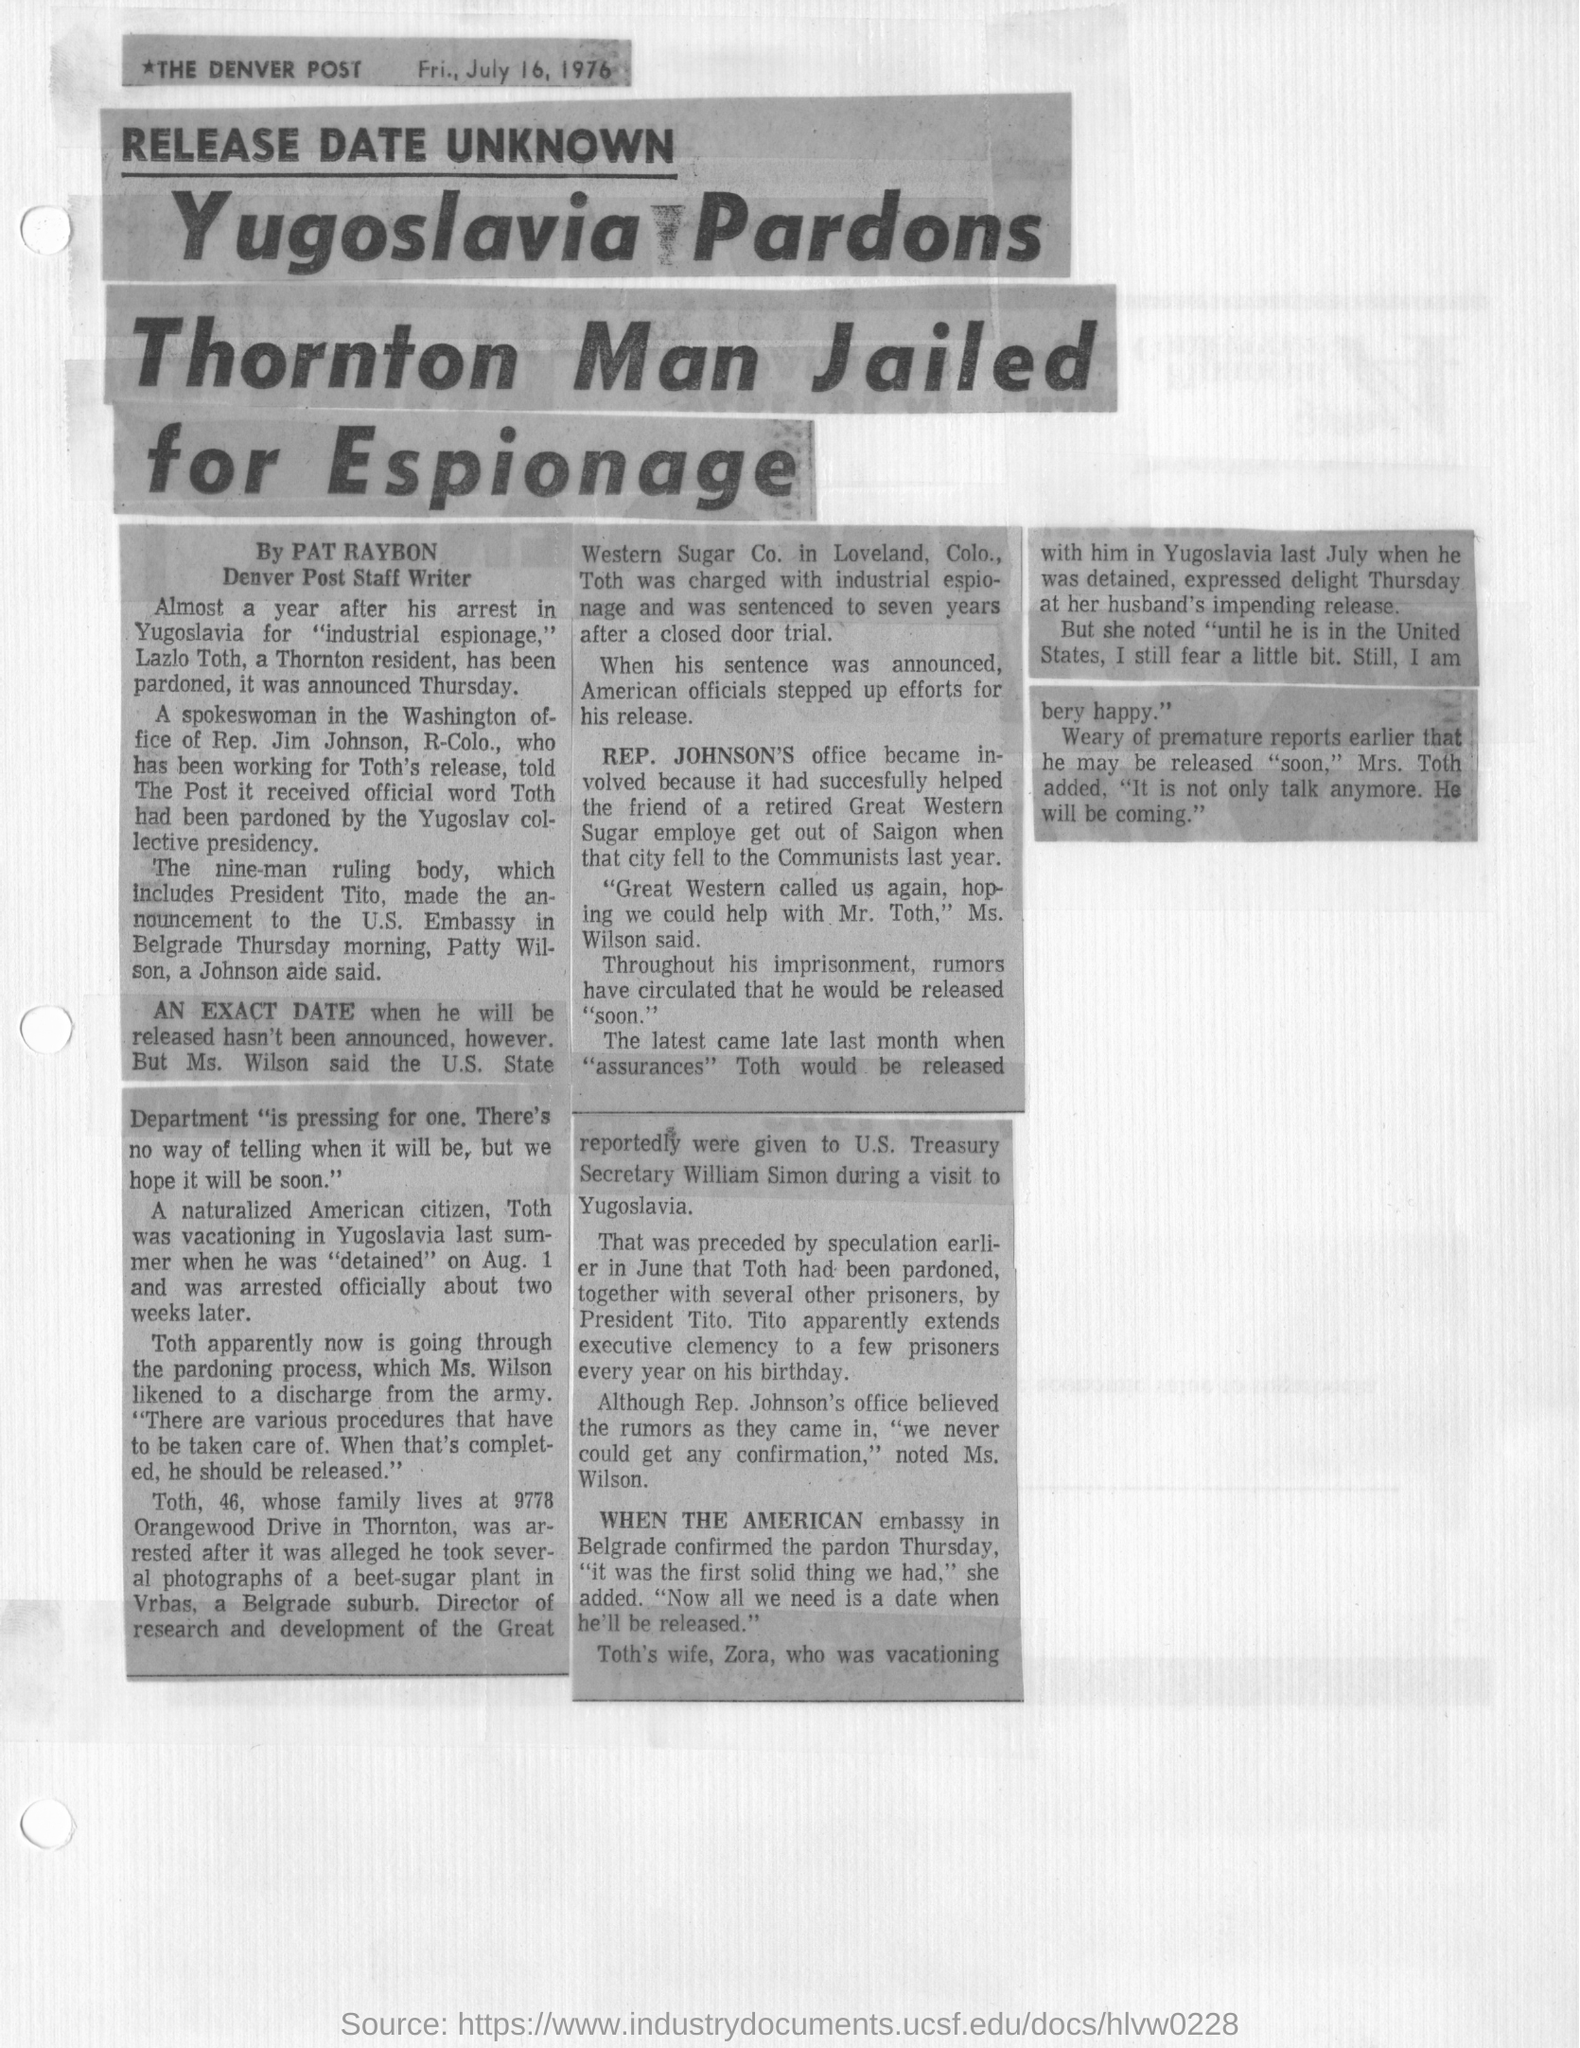Who does Yugoslavia pardon?
Your answer should be compact. Toth. What was Lazlo Toth arrested for?
Keep it short and to the point. Industrial espionage. Which newspaper is the article from?
Give a very brief answer. THE DENVER POST. Which date was the article printed on?
Keep it short and to the point. Fri, July 16, 1976. Which town is Lazlo Toth a resident of?
Give a very brief answer. Thornton. 